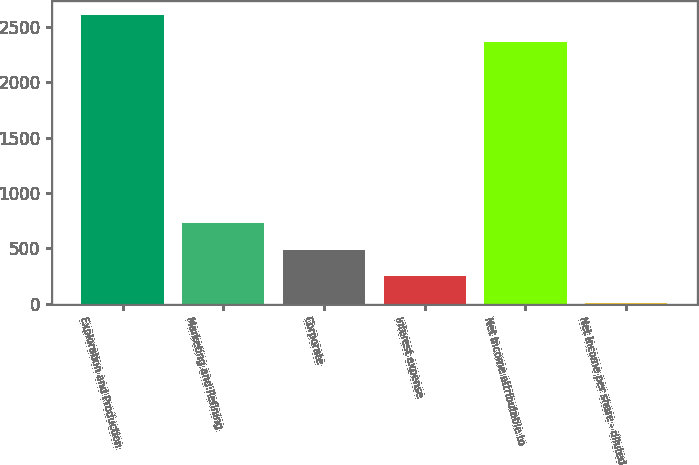Convert chart to OTSL. <chart><loc_0><loc_0><loc_500><loc_500><bar_chart><fcel>Exploration and Production<fcel>Marketing and Refining<fcel>Corporate<fcel>Interest expense<fcel>Net income attributable to<fcel>Net income per share - diluted<nl><fcel>2601.58<fcel>731.98<fcel>490.4<fcel>248.82<fcel>2360<fcel>7.24<nl></chart> 